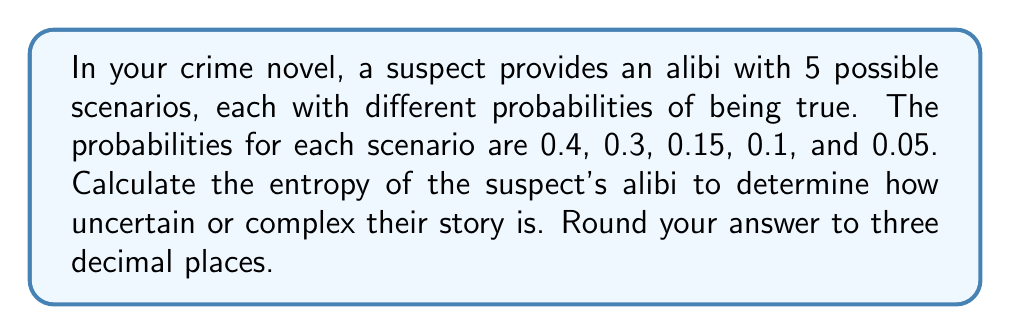Provide a solution to this math problem. To calculate the entropy of the suspect's alibi, we'll use the formula for Shannon entropy:

$$ H = -\sum_{i=1}^{n} p_i \log_2(p_i) $$

Where:
$H$ is the entropy
$p_i$ is the probability of each scenario
$n$ is the number of scenarios

Let's calculate each term:

1. $-0.4 \log_2(0.4) = 0.528321$
2. $-0.3 \log_2(0.3) = 0.521126$
3. $-0.15 \log_2(0.15) = 0.410239$
4. $-0.1 \log_2(0.1) = 0.332193$
5. $-0.05 \log_2(0.05) = 0.216096$

Now, sum all these terms:

$$ H = 0.528321 + 0.521126 + 0.410239 + 0.332193 + 0.216096 = 2.007975 $$

Rounding to three decimal places:

$$ H \approx 2.008 $$

This value represents the average amount of information or uncertainty in the suspect's alibi. A higher entropy indicates a more complex or uncertain alibi, which could be an interesting plot point in your crime novel.
Answer: 2.008 bits 